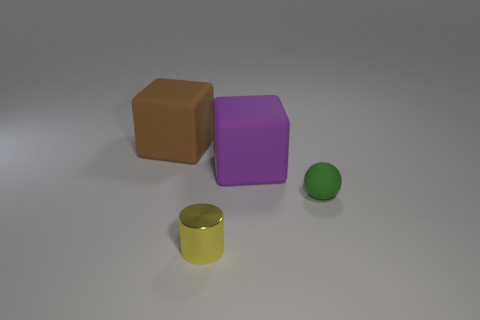Add 2 large yellow shiny objects. How many objects exist? 6 Subtract all cylinders. How many objects are left? 3 Subtract 0 cyan cylinders. How many objects are left? 4 Subtract all yellow rubber cubes. Subtract all brown things. How many objects are left? 3 Add 1 small shiny things. How many small shiny things are left? 2 Add 2 cyan things. How many cyan things exist? 2 